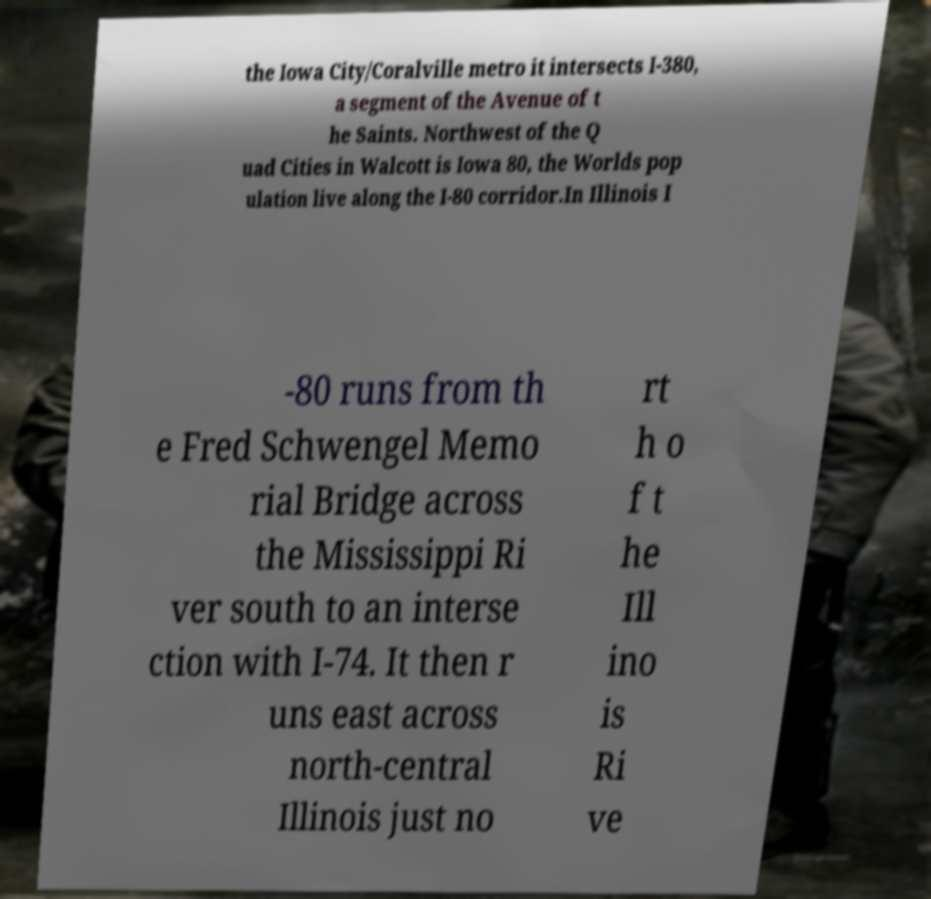There's text embedded in this image that I need extracted. Can you transcribe it verbatim? the Iowa City/Coralville metro it intersects I-380, a segment of the Avenue of t he Saints. Northwest of the Q uad Cities in Walcott is Iowa 80, the Worlds pop ulation live along the I-80 corridor.In Illinois I -80 runs from th e Fred Schwengel Memo rial Bridge across the Mississippi Ri ver south to an interse ction with I-74. It then r uns east across north-central Illinois just no rt h o f t he Ill ino is Ri ve 